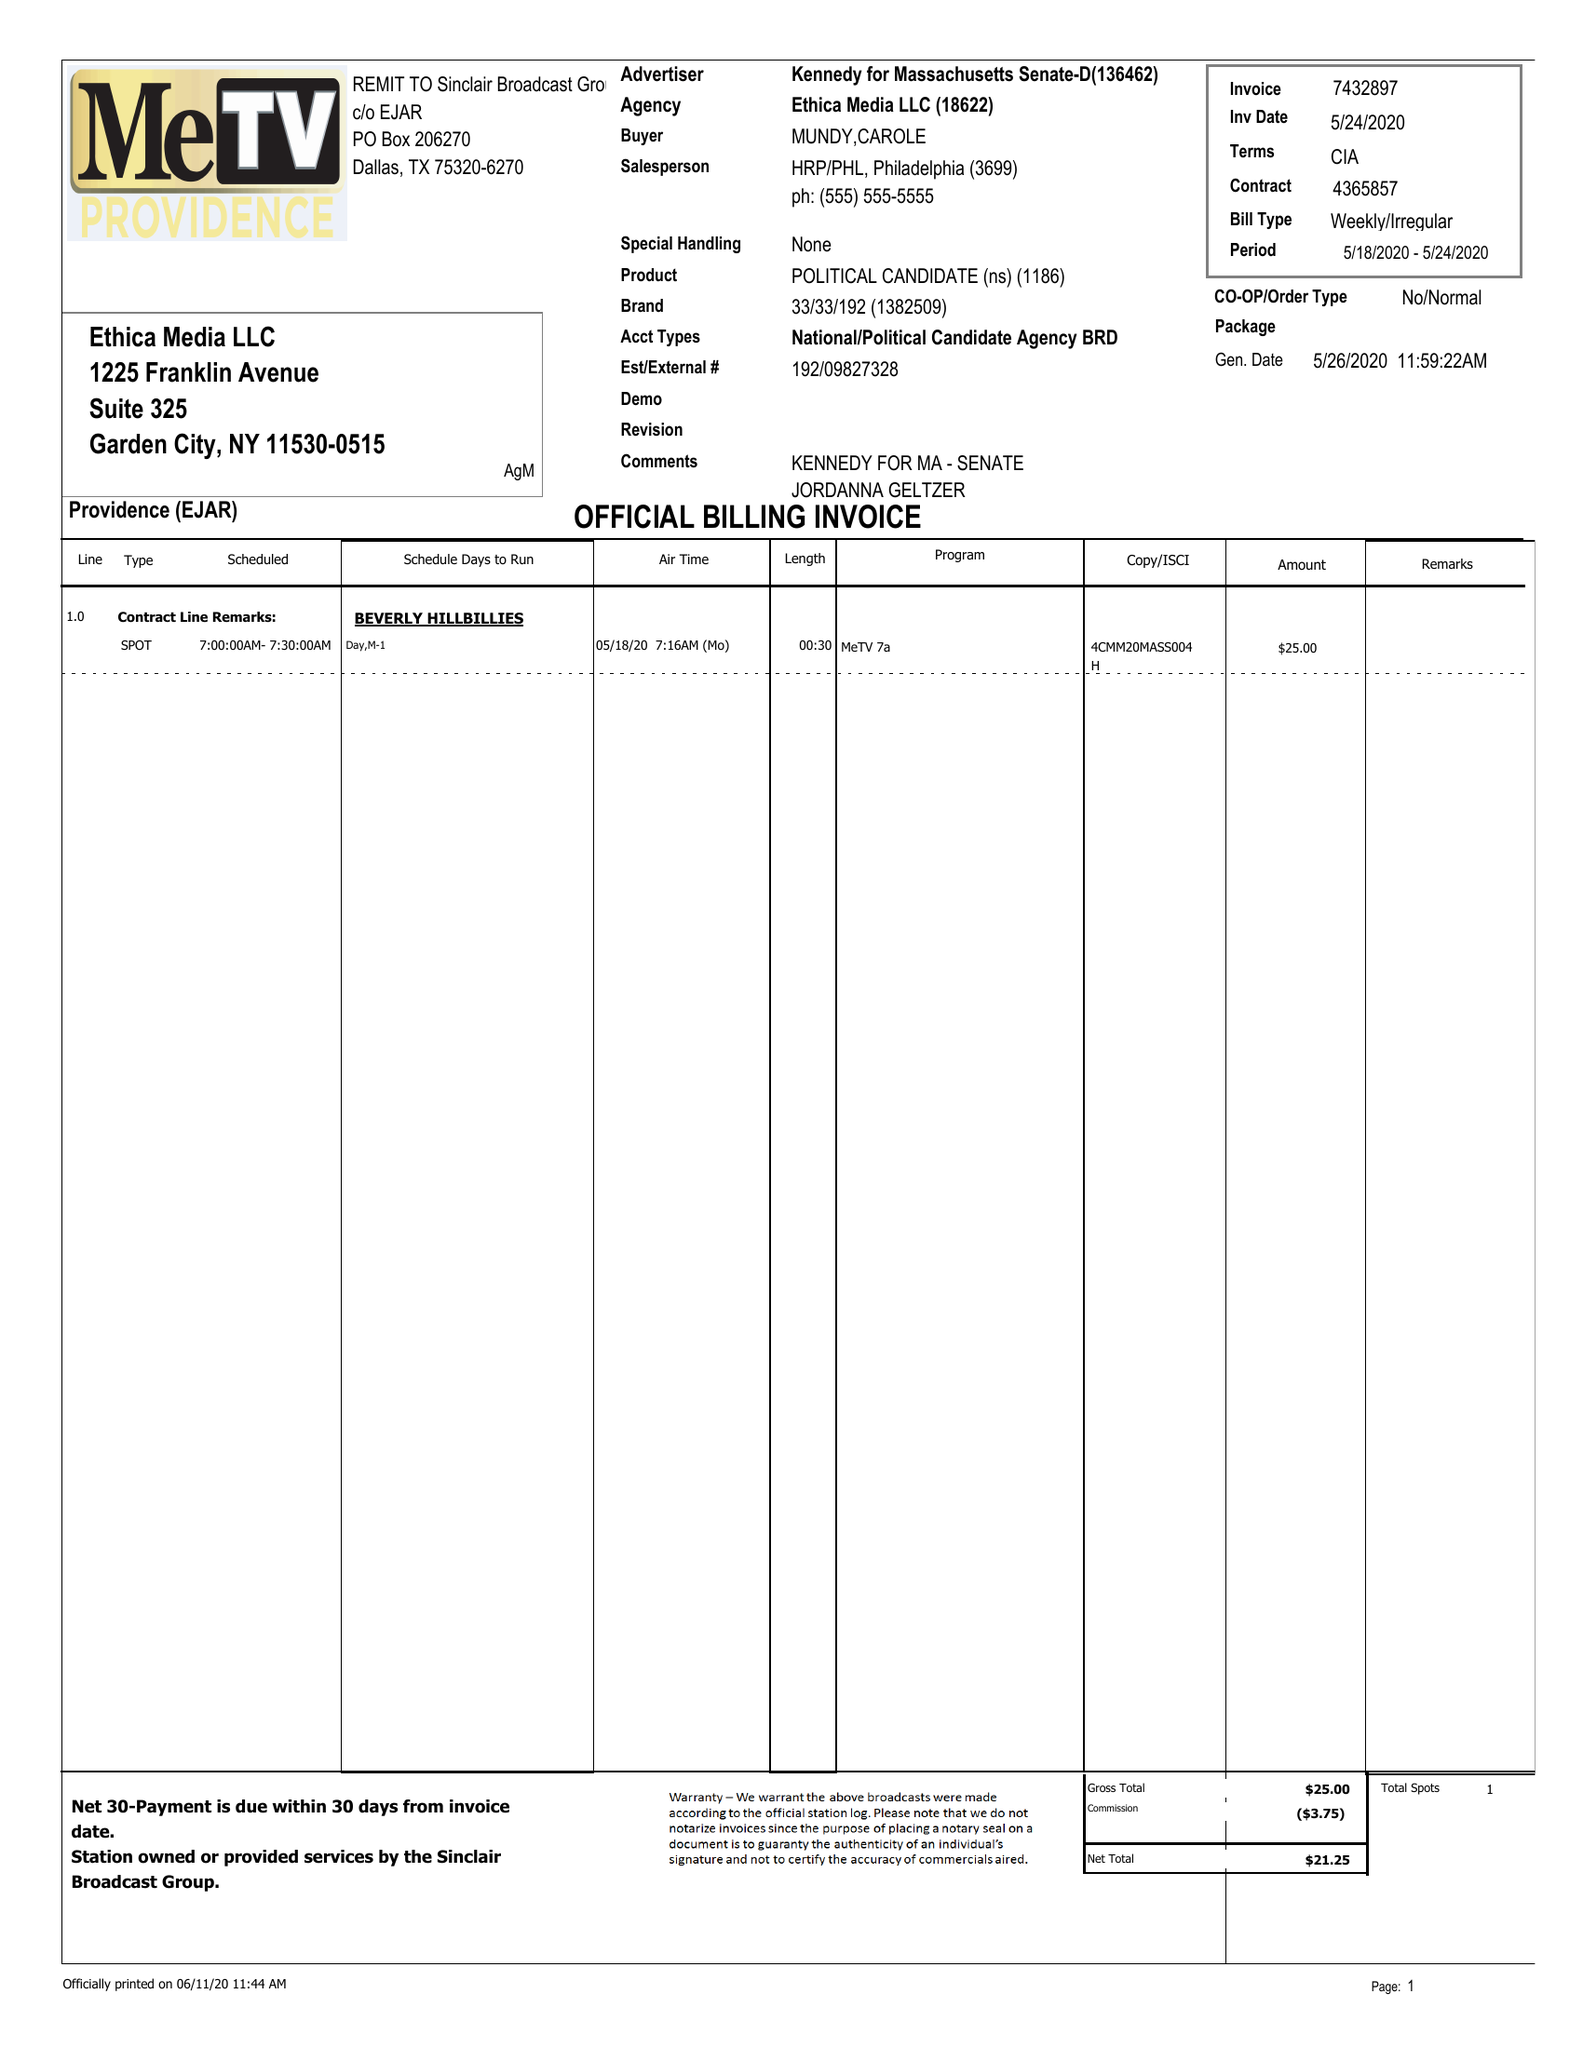What is the value for the contract_num?
Answer the question using a single word or phrase. 4365857 